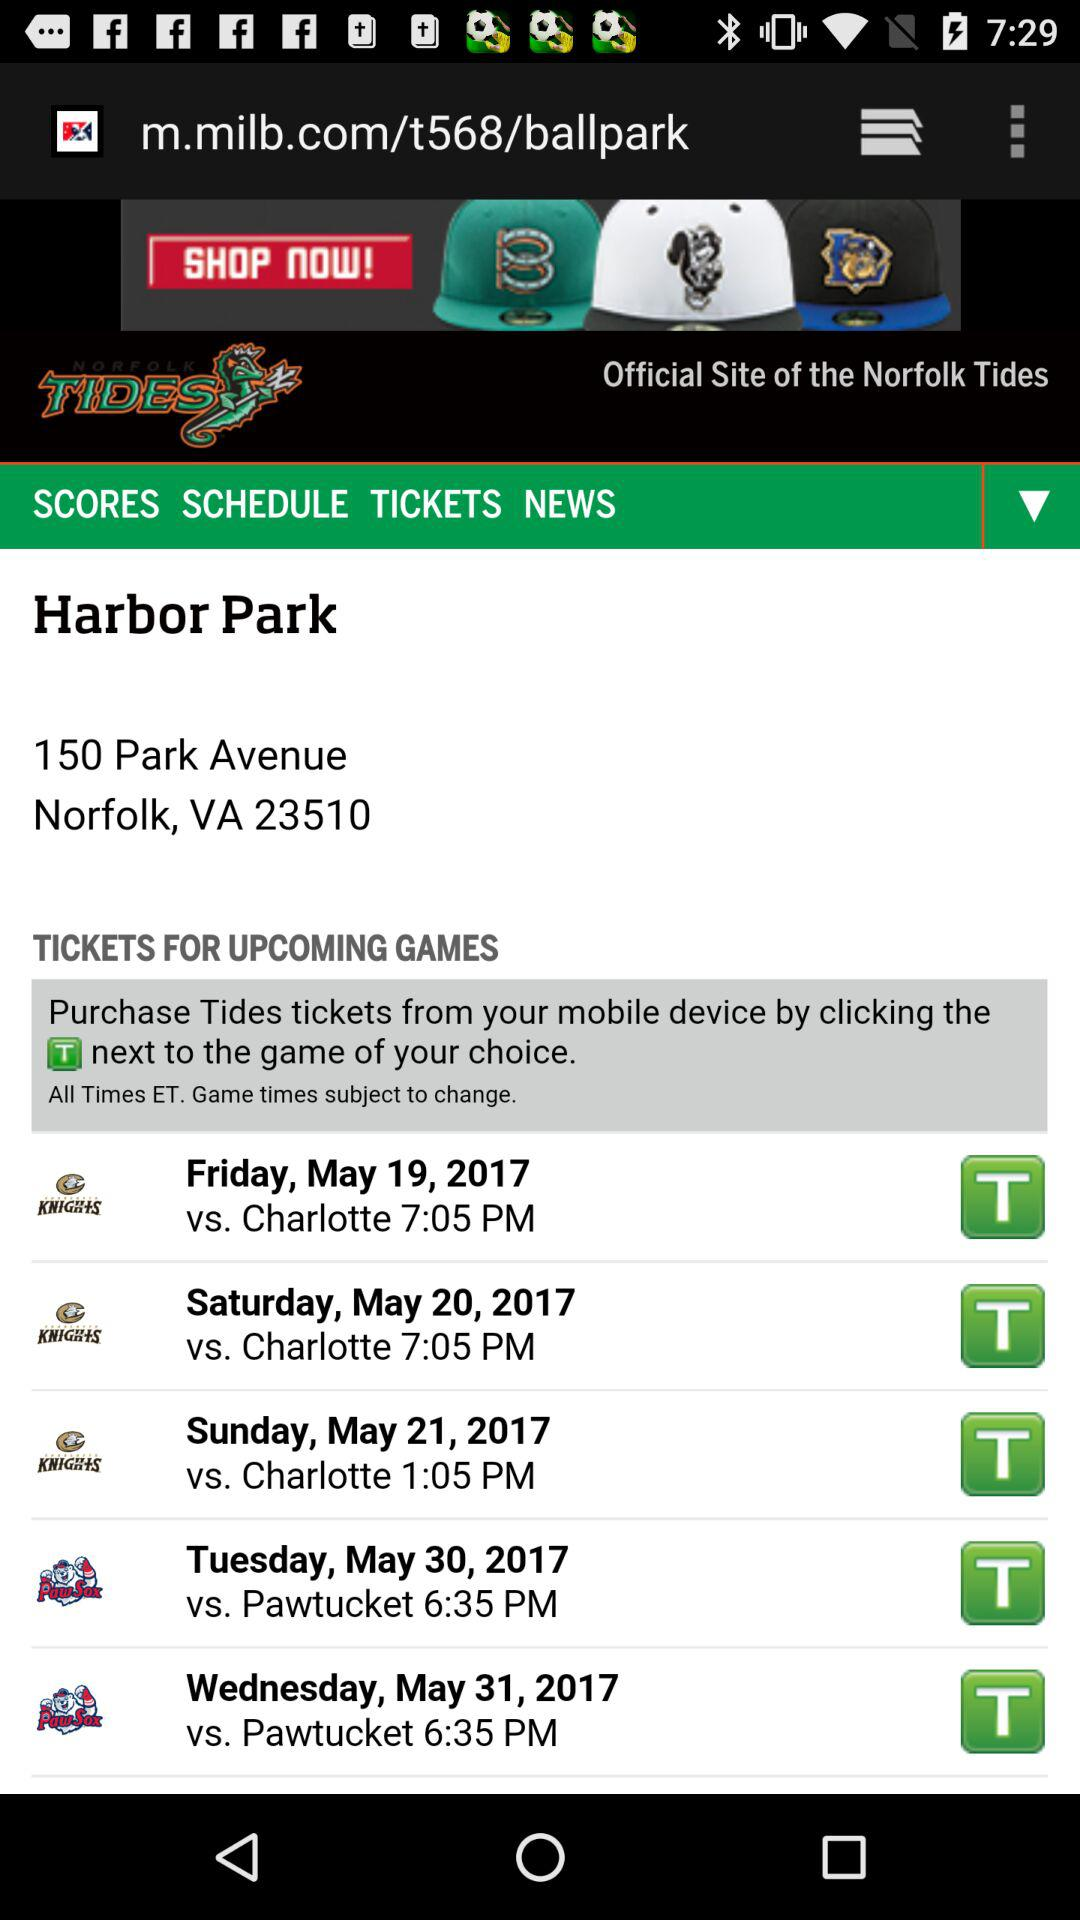What team will play on the 31st of May? The team playing on May 31st is "Pawtucket". 